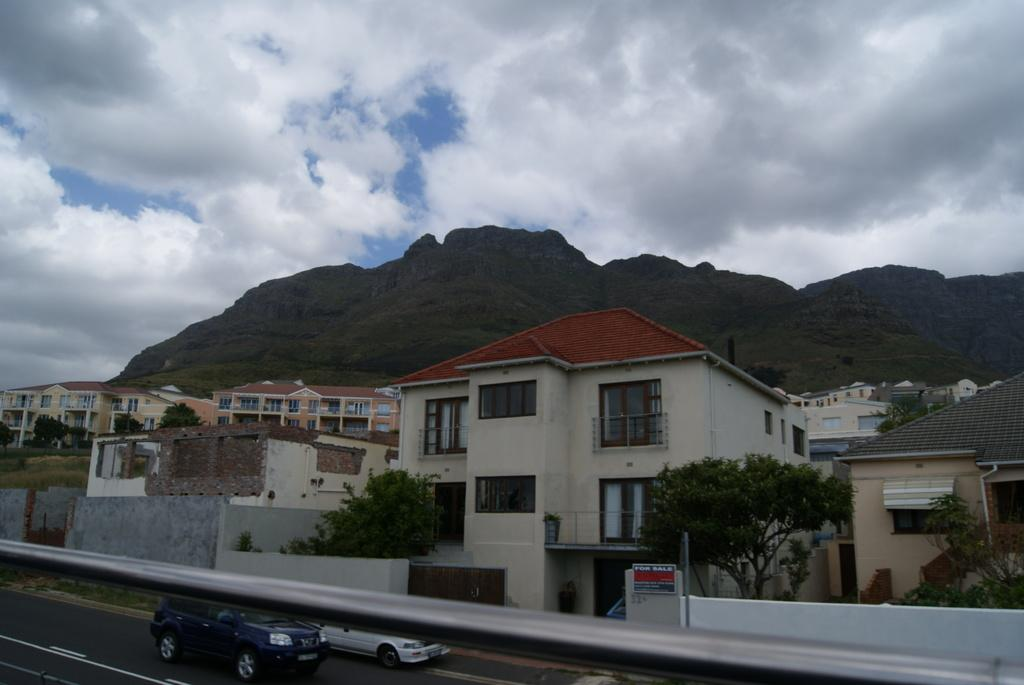What type of structures can be seen in the image? There are buildings in the image. What other natural elements are present in the image? There are trees in the image. What mode of transportation can be seen on the road in the image? There are vehicles on the road in the image. What is visible in the background of the image? There is a mountain and the sky visible in the background of the image. Can you see a yoke being used in the image? There is no yoke present in the image. What type of meat is being cooked on the mountain in the image? There is no meat or cooking activity present in the image; it features buildings, trees, vehicles, and a mountain in the background. 